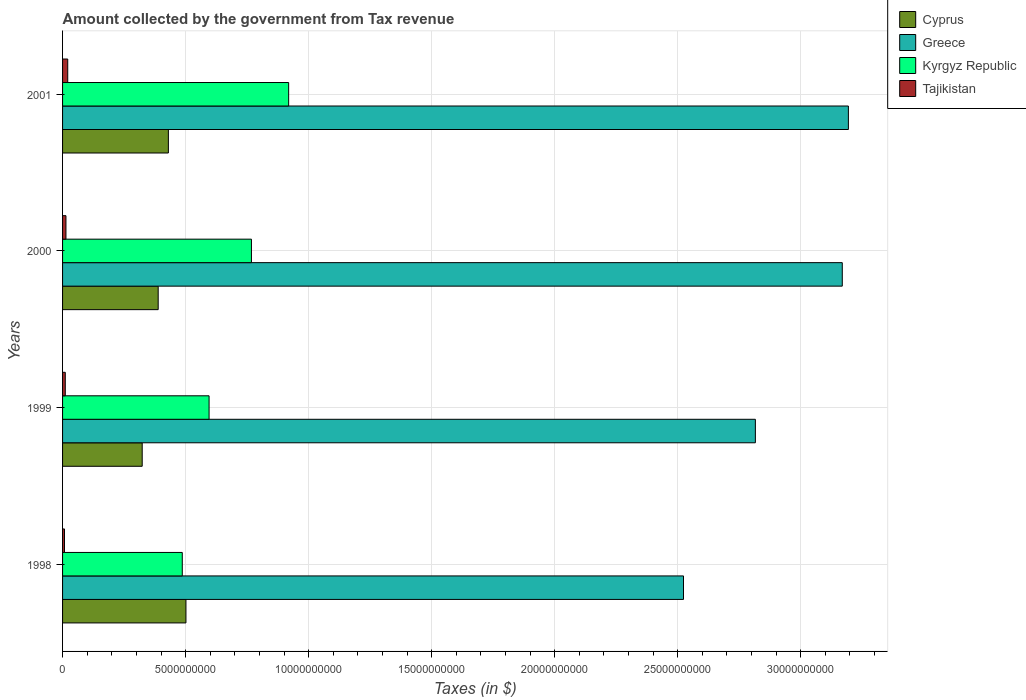How many different coloured bars are there?
Your answer should be compact. 4. How many bars are there on the 1st tick from the top?
Provide a short and direct response. 4. How many bars are there on the 1st tick from the bottom?
Make the answer very short. 4. What is the amount collected by the government from tax revenue in Kyrgyz Republic in 1998?
Provide a short and direct response. 4.87e+09. Across all years, what is the maximum amount collected by the government from tax revenue in Greece?
Ensure brevity in your answer.  3.19e+1. Across all years, what is the minimum amount collected by the government from tax revenue in Tajikistan?
Give a very brief answer. 7.88e+07. In which year was the amount collected by the government from tax revenue in Greece maximum?
Provide a short and direct response. 2001. In which year was the amount collected by the government from tax revenue in Greece minimum?
Your answer should be very brief. 1998. What is the total amount collected by the government from tax revenue in Cyprus in the graph?
Give a very brief answer. 1.64e+1. What is the difference between the amount collected by the government from tax revenue in Kyrgyz Republic in 1998 and that in 2001?
Make the answer very short. -4.32e+09. What is the difference between the amount collected by the government from tax revenue in Kyrgyz Republic in 2000 and the amount collected by the government from tax revenue in Tajikistan in 1998?
Your response must be concise. 7.60e+09. What is the average amount collected by the government from tax revenue in Cyprus per year?
Offer a very short reply. 4.11e+09. In the year 2000, what is the difference between the amount collected by the government from tax revenue in Cyprus and amount collected by the government from tax revenue in Kyrgyz Republic?
Provide a succinct answer. -3.79e+09. What is the ratio of the amount collected by the government from tax revenue in Cyprus in 1998 to that in 1999?
Your response must be concise. 1.55. Is the amount collected by the government from tax revenue in Cyprus in 1999 less than that in 2001?
Provide a succinct answer. Yes. Is the difference between the amount collected by the government from tax revenue in Cyprus in 2000 and 2001 greater than the difference between the amount collected by the government from tax revenue in Kyrgyz Republic in 2000 and 2001?
Provide a succinct answer. Yes. What is the difference between the highest and the second highest amount collected by the government from tax revenue in Kyrgyz Republic?
Ensure brevity in your answer.  1.51e+09. What is the difference between the highest and the lowest amount collected by the government from tax revenue in Tajikistan?
Offer a very short reply. 1.31e+08. Is it the case that in every year, the sum of the amount collected by the government from tax revenue in Kyrgyz Republic and amount collected by the government from tax revenue in Cyprus is greater than the sum of amount collected by the government from tax revenue in Tajikistan and amount collected by the government from tax revenue in Greece?
Ensure brevity in your answer.  No. What does the 3rd bar from the top in 2000 represents?
Offer a very short reply. Greece. What does the 4th bar from the bottom in 1998 represents?
Offer a terse response. Tajikistan. How many bars are there?
Offer a terse response. 16. How many years are there in the graph?
Make the answer very short. 4. What is the difference between two consecutive major ticks on the X-axis?
Your answer should be compact. 5.00e+09. Does the graph contain grids?
Offer a very short reply. Yes. What is the title of the graph?
Keep it short and to the point. Amount collected by the government from Tax revenue. What is the label or title of the X-axis?
Your answer should be very brief. Taxes (in $). What is the label or title of the Y-axis?
Your answer should be compact. Years. What is the Taxes (in $) of Cyprus in 1998?
Provide a succinct answer. 5.01e+09. What is the Taxes (in $) of Greece in 1998?
Your answer should be compact. 2.52e+1. What is the Taxes (in $) in Kyrgyz Republic in 1998?
Ensure brevity in your answer.  4.87e+09. What is the Taxes (in $) in Tajikistan in 1998?
Give a very brief answer. 7.88e+07. What is the Taxes (in $) of Cyprus in 1999?
Your answer should be very brief. 3.24e+09. What is the Taxes (in $) of Greece in 1999?
Your answer should be very brief. 2.82e+1. What is the Taxes (in $) in Kyrgyz Republic in 1999?
Offer a very short reply. 5.95e+09. What is the Taxes (in $) of Tajikistan in 1999?
Your answer should be very brief. 1.10e+08. What is the Taxes (in $) of Cyprus in 2000?
Make the answer very short. 3.89e+09. What is the Taxes (in $) in Greece in 2000?
Your answer should be very brief. 3.17e+1. What is the Taxes (in $) of Kyrgyz Republic in 2000?
Offer a very short reply. 7.68e+09. What is the Taxes (in $) of Tajikistan in 2000?
Your answer should be very brief. 1.38e+08. What is the Taxes (in $) of Cyprus in 2001?
Your response must be concise. 4.30e+09. What is the Taxes (in $) of Greece in 2001?
Provide a short and direct response. 3.19e+1. What is the Taxes (in $) in Kyrgyz Republic in 2001?
Your response must be concise. 9.19e+09. What is the Taxes (in $) of Tajikistan in 2001?
Provide a short and direct response. 2.10e+08. Across all years, what is the maximum Taxes (in $) in Cyprus?
Make the answer very short. 5.01e+09. Across all years, what is the maximum Taxes (in $) of Greece?
Your response must be concise. 3.19e+1. Across all years, what is the maximum Taxes (in $) of Kyrgyz Republic?
Your answer should be compact. 9.19e+09. Across all years, what is the maximum Taxes (in $) in Tajikistan?
Provide a short and direct response. 2.10e+08. Across all years, what is the minimum Taxes (in $) in Cyprus?
Provide a succinct answer. 3.24e+09. Across all years, what is the minimum Taxes (in $) in Greece?
Your answer should be very brief. 2.52e+1. Across all years, what is the minimum Taxes (in $) in Kyrgyz Republic?
Provide a succinct answer. 4.87e+09. Across all years, what is the minimum Taxes (in $) of Tajikistan?
Your response must be concise. 7.88e+07. What is the total Taxes (in $) in Cyprus in the graph?
Offer a terse response. 1.64e+1. What is the total Taxes (in $) of Greece in the graph?
Provide a short and direct response. 1.17e+11. What is the total Taxes (in $) of Kyrgyz Republic in the graph?
Provide a succinct answer. 2.77e+1. What is the total Taxes (in $) of Tajikistan in the graph?
Your answer should be very brief. 5.37e+08. What is the difference between the Taxes (in $) in Cyprus in 1998 and that in 1999?
Offer a very short reply. 1.78e+09. What is the difference between the Taxes (in $) of Greece in 1998 and that in 1999?
Make the answer very short. -2.92e+09. What is the difference between the Taxes (in $) in Kyrgyz Republic in 1998 and that in 1999?
Make the answer very short. -1.09e+09. What is the difference between the Taxes (in $) in Tajikistan in 1998 and that in 1999?
Provide a short and direct response. -3.16e+07. What is the difference between the Taxes (in $) in Cyprus in 1998 and that in 2000?
Your answer should be very brief. 1.13e+09. What is the difference between the Taxes (in $) of Greece in 1998 and that in 2000?
Provide a short and direct response. -6.45e+09. What is the difference between the Taxes (in $) of Kyrgyz Republic in 1998 and that in 2000?
Ensure brevity in your answer.  -2.81e+09. What is the difference between the Taxes (in $) in Tajikistan in 1998 and that in 2000?
Your answer should be very brief. -5.88e+07. What is the difference between the Taxes (in $) in Cyprus in 1998 and that in 2001?
Ensure brevity in your answer.  7.14e+08. What is the difference between the Taxes (in $) in Greece in 1998 and that in 2001?
Your response must be concise. -6.70e+09. What is the difference between the Taxes (in $) of Kyrgyz Republic in 1998 and that in 2001?
Offer a very short reply. -4.32e+09. What is the difference between the Taxes (in $) of Tajikistan in 1998 and that in 2001?
Keep it short and to the point. -1.31e+08. What is the difference between the Taxes (in $) in Cyprus in 1999 and that in 2000?
Ensure brevity in your answer.  -6.50e+08. What is the difference between the Taxes (in $) of Greece in 1999 and that in 2000?
Your response must be concise. -3.53e+09. What is the difference between the Taxes (in $) of Kyrgyz Republic in 1999 and that in 2000?
Your answer should be compact. -1.72e+09. What is the difference between the Taxes (in $) in Tajikistan in 1999 and that in 2000?
Your response must be concise. -2.72e+07. What is the difference between the Taxes (in $) in Cyprus in 1999 and that in 2001?
Provide a short and direct response. -1.06e+09. What is the difference between the Taxes (in $) in Greece in 1999 and that in 2001?
Your answer should be very brief. -3.78e+09. What is the difference between the Taxes (in $) of Kyrgyz Republic in 1999 and that in 2001?
Give a very brief answer. -3.23e+09. What is the difference between the Taxes (in $) of Tajikistan in 1999 and that in 2001?
Offer a very short reply. -9.99e+07. What is the difference between the Taxes (in $) of Cyprus in 2000 and that in 2001?
Offer a terse response. -4.14e+08. What is the difference between the Taxes (in $) in Greece in 2000 and that in 2001?
Offer a terse response. -2.48e+08. What is the difference between the Taxes (in $) of Kyrgyz Republic in 2000 and that in 2001?
Ensure brevity in your answer.  -1.51e+09. What is the difference between the Taxes (in $) in Tajikistan in 2000 and that in 2001?
Your answer should be compact. -7.26e+07. What is the difference between the Taxes (in $) of Cyprus in 1998 and the Taxes (in $) of Greece in 1999?
Your answer should be compact. -2.31e+1. What is the difference between the Taxes (in $) of Cyprus in 1998 and the Taxes (in $) of Kyrgyz Republic in 1999?
Offer a very short reply. -9.40e+08. What is the difference between the Taxes (in $) in Cyprus in 1998 and the Taxes (in $) in Tajikistan in 1999?
Your answer should be compact. 4.90e+09. What is the difference between the Taxes (in $) in Greece in 1998 and the Taxes (in $) in Kyrgyz Republic in 1999?
Your response must be concise. 1.93e+1. What is the difference between the Taxes (in $) of Greece in 1998 and the Taxes (in $) of Tajikistan in 1999?
Provide a succinct answer. 2.51e+1. What is the difference between the Taxes (in $) of Kyrgyz Republic in 1998 and the Taxes (in $) of Tajikistan in 1999?
Provide a short and direct response. 4.75e+09. What is the difference between the Taxes (in $) of Cyprus in 1998 and the Taxes (in $) of Greece in 2000?
Your answer should be compact. -2.67e+1. What is the difference between the Taxes (in $) in Cyprus in 1998 and the Taxes (in $) in Kyrgyz Republic in 2000?
Ensure brevity in your answer.  -2.66e+09. What is the difference between the Taxes (in $) in Cyprus in 1998 and the Taxes (in $) in Tajikistan in 2000?
Provide a short and direct response. 4.88e+09. What is the difference between the Taxes (in $) of Greece in 1998 and the Taxes (in $) of Kyrgyz Republic in 2000?
Your answer should be very brief. 1.76e+1. What is the difference between the Taxes (in $) of Greece in 1998 and the Taxes (in $) of Tajikistan in 2000?
Offer a terse response. 2.51e+1. What is the difference between the Taxes (in $) in Kyrgyz Republic in 1998 and the Taxes (in $) in Tajikistan in 2000?
Your response must be concise. 4.73e+09. What is the difference between the Taxes (in $) in Cyprus in 1998 and the Taxes (in $) in Greece in 2001?
Your response must be concise. -2.69e+1. What is the difference between the Taxes (in $) in Cyprus in 1998 and the Taxes (in $) in Kyrgyz Republic in 2001?
Give a very brief answer. -4.17e+09. What is the difference between the Taxes (in $) of Cyprus in 1998 and the Taxes (in $) of Tajikistan in 2001?
Provide a short and direct response. 4.80e+09. What is the difference between the Taxes (in $) of Greece in 1998 and the Taxes (in $) of Kyrgyz Republic in 2001?
Keep it short and to the point. 1.60e+1. What is the difference between the Taxes (in $) in Greece in 1998 and the Taxes (in $) in Tajikistan in 2001?
Provide a succinct answer. 2.50e+1. What is the difference between the Taxes (in $) of Kyrgyz Republic in 1998 and the Taxes (in $) of Tajikistan in 2001?
Provide a short and direct response. 4.65e+09. What is the difference between the Taxes (in $) of Cyprus in 1999 and the Taxes (in $) of Greece in 2000?
Your answer should be very brief. -2.85e+1. What is the difference between the Taxes (in $) in Cyprus in 1999 and the Taxes (in $) in Kyrgyz Republic in 2000?
Your answer should be very brief. -4.44e+09. What is the difference between the Taxes (in $) of Cyprus in 1999 and the Taxes (in $) of Tajikistan in 2000?
Your response must be concise. 3.10e+09. What is the difference between the Taxes (in $) in Greece in 1999 and the Taxes (in $) in Kyrgyz Republic in 2000?
Your answer should be compact. 2.05e+1. What is the difference between the Taxes (in $) of Greece in 1999 and the Taxes (in $) of Tajikistan in 2000?
Give a very brief answer. 2.80e+1. What is the difference between the Taxes (in $) of Kyrgyz Republic in 1999 and the Taxes (in $) of Tajikistan in 2000?
Provide a succinct answer. 5.82e+09. What is the difference between the Taxes (in $) in Cyprus in 1999 and the Taxes (in $) in Greece in 2001?
Keep it short and to the point. -2.87e+1. What is the difference between the Taxes (in $) in Cyprus in 1999 and the Taxes (in $) in Kyrgyz Republic in 2001?
Provide a succinct answer. -5.95e+09. What is the difference between the Taxes (in $) in Cyprus in 1999 and the Taxes (in $) in Tajikistan in 2001?
Provide a succinct answer. 3.03e+09. What is the difference between the Taxes (in $) in Greece in 1999 and the Taxes (in $) in Kyrgyz Republic in 2001?
Give a very brief answer. 1.90e+1. What is the difference between the Taxes (in $) in Greece in 1999 and the Taxes (in $) in Tajikistan in 2001?
Your answer should be very brief. 2.79e+1. What is the difference between the Taxes (in $) in Kyrgyz Republic in 1999 and the Taxes (in $) in Tajikistan in 2001?
Ensure brevity in your answer.  5.74e+09. What is the difference between the Taxes (in $) in Cyprus in 2000 and the Taxes (in $) in Greece in 2001?
Keep it short and to the point. -2.80e+1. What is the difference between the Taxes (in $) of Cyprus in 2000 and the Taxes (in $) of Kyrgyz Republic in 2001?
Offer a very short reply. -5.30e+09. What is the difference between the Taxes (in $) of Cyprus in 2000 and the Taxes (in $) of Tajikistan in 2001?
Offer a terse response. 3.68e+09. What is the difference between the Taxes (in $) in Greece in 2000 and the Taxes (in $) in Kyrgyz Republic in 2001?
Your response must be concise. 2.25e+1. What is the difference between the Taxes (in $) in Greece in 2000 and the Taxes (in $) in Tajikistan in 2001?
Make the answer very short. 3.15e+1. What is the difference between the Taxes (in $) in Kyrgyz Republic in 2000 and the Taxes (in $) in Tajikistan in 2001?
Provide a short and direct response. 7.47e+09. What is the average Taxes (in $) of Cyprus per year?
Your answer should be very brief. 4.11e+09. What is the average Taxes (in $) in Greece per year?
Provide a short and direct response. 2.93e+1. What is the average Taxes (in $) of Kyrgyz Republic per year?
Provide a succinct answer. 6.92e+09. What is the average Taxes (in $) of Tajikistan per year?
Your answer should be compact. 1.34e+08. In the year 1998, what is the difference between the Taxes (in $) of Cyprus and Taxes (in $) of Greece?
Your answer should be compact. -2.02e+1. In the year 1998, what is the difference between the Taxes (in $) in Cyprus and Taxes (in $) in Kyrgyz Republic?
Make the answer very short. 1.49e+08. In the year 1998, what is the difference between the Taxes (in $) of Cyprus and Taxes (in $) of Tajikistan?
Offer a very short reply. 4.94e+09. In the year 1998, what is the difference between the Taxes (in $) of Greece and Taxes (in $) of Kyrgyz Republic?
Keep it short and to the point. 2.04e+1. In the year 1998, what is the difference between the Taxes (in $) in Greece and Taxes (in $) in Tajikistan?
Offer a very short reply. 2.52e+1. In the year 1998, what is the difference between the Taxes (in $) of Kyrgyz Republic and Taxes (in $) of Tajikistan?
Your answer should be compact. 4.79e+09. In the year 1999, what is the difference between the Taxes (in $) in Cyprus and Taxes (in $) in Greece?
Provide a succinct answer. -2.49e+1. In the year 1999, what is the difference between the Taxes (in $) of Cyprus and Taxes (in $) of Kyrgyz Republic?
Provide a succinct answer. -2.72e+09. In the year 1999, what is the difference between the Taxes (in $) in Cyprus and Taxes (in $) in Tajikistan?
Keep it short and to the point. 3.13e+09. In the year 1999, what is the difference between the Taxes (in $) of Greece and Taxes (in $) of Kyrgyz Republic?
Your answer should be very brief. 2.22e+1. In the year 1999, what is the difference between the Taxes (in $) of Greece and Taxes (in $) of Tajikistan?
Provide a succinct answer. 2.80e+1. In the year 1999, what is the difference between the Taxes (in $) in Kyrgyz Republic and Taxes (in $) in Tajikistan?
Provide a succinct answer. 5.84e+09. In the year 2000, what is the difference between the Taxes (in $) in Cyprus and Taxes (in $) in Greece?
Your answer should be compact. -2.78e+1. In the year 2000, what is the difference between the Taxes (in $) in Cyprus and Taxes (in $) in Kyrgyz Republic?
Your response must be concise. -3.79e+09. In the year 2000, what is the difference between the Taxes (in $) in Cyprus and Taxes (in $) in Tajikistan?
Keep it short and to the point. 3.75e+09. In the year 2000, what is the difference between the Taxes (in $) in Greece and Taxes (in $) in Kyrgyz Republic?
Offer a terse response. 2.40e+1. In the year 2000, what is the difference between the Taxes (in $) of Greece and Taxes (in $) of Tajikistan?
Your answer should be compact. 3.15e+1. In the year 2000, what is the difference between the Taxes (in $) of Kyrgyz Republic and Taxes (in $) of Tajikistan?
Your answer should be very brief. 7.54e+09. In the year 2001, what is the difference between the Taxes (in $) of Cyprus and Taxes (in $) of Greece?
Offer a terse response. -2.76e+1. In the year 2001, what is the difference between the Taxes (in $) in Cyprus and Taxes (in $) in Kyrgyz Republic?
Ensure brevity in your answer.  -4.89e+09. In the year 2001, what is the difference between the Taxes (in $) of Cyprus and Taxes (in $) of Tajikistan?
Your response must be concise. 4.09e+09. In the year 2001, what is the difference between the Taxes (in $) of Greece and Taxes (in $) of Kyrgyz Republic?
Your response must be concise. 2.27e+1. In the year 2001, what is the difference between the Taxes (in $) in Greece and Taxes (in $) in Tajikistan?
Provide a succinct answer. 3.17e+1. In the year 2001, what is the difference between the Taxes (in $) in Kyrgyz Republic and Taxes (in $) in Tajikistan?
Provide a short and direct response. 8.98e+09. What is the ratio of the Taxes (in $) of Cyprus in 1998 to that in 1999?
Ensure brevity in your answer.  1.55. What is the ratio of the Taxes (in $) of Greece in 1998 to that in 1999?
Make the answer very short. 0.9. What is the ratio of the Taxes (in $) in Kyrgyz Republic in 1998 to that in 1999?
Make the answer very short. 0.82. What is the ratio of the Taxes (in $) in Tajikistan in 1998 to that in 1999?
Give a very brief answer. 0.71. What is the ratio of the Taxes (in $) of Cyprus in 1998 to that in 2000?
Provide a succinct answer. 1.29. What is the ratio of the Taxes (in $) of Greece in 1998 to that in 2000?
Offer a terse response. 0.8. What is the ratio of the Taxes (in $) in Kyrgyz Republic in 1998 to that in 2000?
Provide a succinct answer. 0.63. What is the ratio of the Taxes (in $) of Tajikistan in 1998 to that in 2000?
Offer a very short reply. 0.57. What is the ratio of the Taxes (in $) of Cyprus in 1998 to that in 2001?
Give a very brief answer. 1.17. What is the ratio of the Taxes (in $) of Greece in 1998 to that in 2001?
Provide a succinct answer. 0.79. What is the ratio of the Taxes (in $) of Kyrgyz Republic in 1998 to that in 2001?
Make the answer very short. 0.53. What is the ratio of the Taxes (in $) of Tajikistan in 1998 to that in 2001?
Your response must be concise. 0.37. What is the ratio of the Taxes (in $) in Cyprus in 1999 to that in 2000?
Offer a very short reply. 0.83. What is the ratio of the Taxes (in $) of Greece in 1999 to that in 2000?
Provide a succinct answer. 0.89. What is the ratio of the Taxes (in $) of Kyrgyz Republic in 1999 to that in 2000?
Your answer should be compact. 0.78. What is the ratio of the Taxes (in $) of Tajikistan in 1999 to that in 2000?
Provide a short and direct response. 0.8. What is the ratio of the Taxes (in $) in Cyprus in 1999 to that in 2001?
Provide a succinct answer. 0.75. What is the ratio of the Taxes (in $) in Greece in 1999 to that in 2001?
Keep it short and to the point. 0.88. What is the ratio of the Taxes (in $) in Kyrgyz Republic in 1999 to that in 2001?
Make the answer very short. 0.65. What is the ratio of the Taxes (in $) in Tajikistan in 1999 to that in 2001?
Your answer should be compact. 0.53. What is the ratio of the Taxes (in $) of Cyprus in 2000 to that in 2001?
Provide a short and direct response. 0.9. What is the ratio of the Taxes (in $) of Greece in 2000 to that in 2001?
Provide a succinct answer. 0.99. What is the ratio of the Taxes (in $) in Kyrgyz Republic in 2000 to that in 2001?
Offer a very short reply. 0.84. What is the ratio of the Taxes (in $) of Tajikistan in 2000 to that in 2001?
Your answer should be compact. 0.65. What is the difference between the highest and the second highest Taxes (in $) of Cyprus?
Offer a very short reply. 7.14e+08. What is the difference between the highest and the second highest Taxes (in $) in Greece?
Give a very brief answer. 2.48e+08. What is the difference between the highest and the second highest Taxes (in $) of Kyrgyz Republic?
Offer a terse response. 1.51e+09. What is the difference between the highest and the second highest Taxes (in $) in Tajikistan?
Keep it short and to the point. 7.26e+07. What is the difference between the highest and the lowest Taxes (in $) of Cyprus?
Your answer should be very brief. 1.78e+09. What is the difference between the highest and the lowest Taxes (in $) of Greece?
Your answer should be very brief. 6.70e+09. What is the difference between the highest and the lowest Taxes (in $) of Kyrgyz Republic?
Your answer should be compact. 4.32e+09. What is the difference between the highest and the lowest Taxes (in $) in Tajikistan?
Make the answer very short. 1.31e+08. 